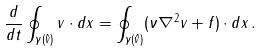<formula> <loc_0><loc_0><loc_500><loc_500>\frac { d } { d t } \oint _ { \gamma ( \hat { v } ) } v \cdot d x = \oint _ { \gamma ( \hat { v } ) } ( \nu \nabla ^ { 2 } v + f ) \cdot d x \, .</formula> 